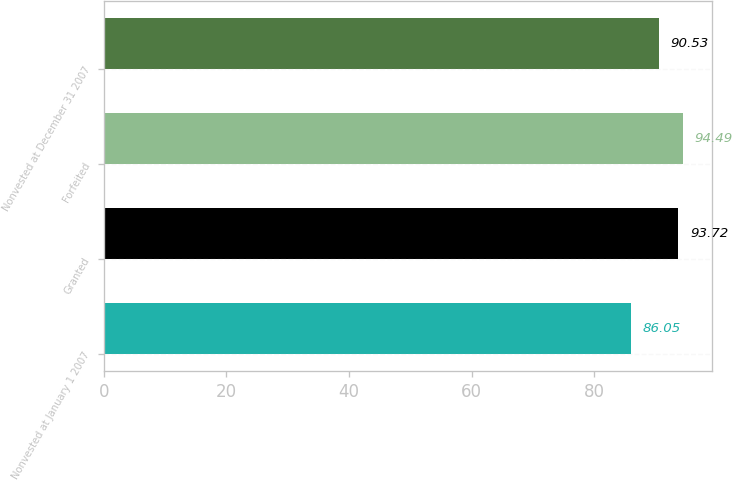Convert chart. <chart><loc_0><loc_0><loc_500><loc_500><bar_chart><fcel>Nonvested at January 1 2007<fcel>Granted<fcel>Forfeited<fcel>Nonvested at December 31 2007<nl><fcel>86.05<fcel>93.72<fcel>94.49<fcel>90.53<nl></chart> 